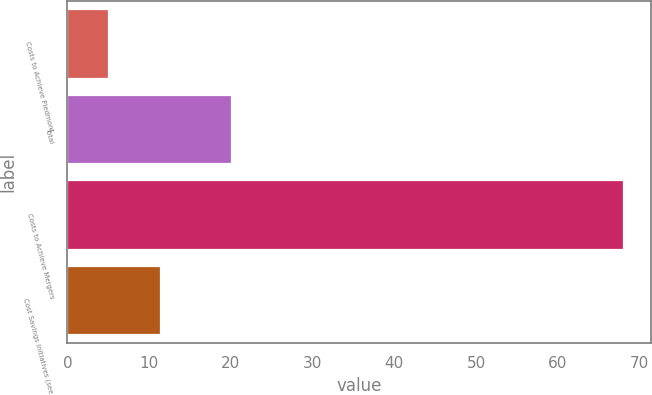<chart> <loc_0><loc_0><loc_500><loc_500><bar_chart><fcel>Costs to Achieve Piedmont<fcel>Total<fcel>Costs to Achieve Mergers<fcel>Cost Savings Initiatives (see<nl><fcel>5<fcel>20<fcel>68<fcel>11.3<nl></chart> 